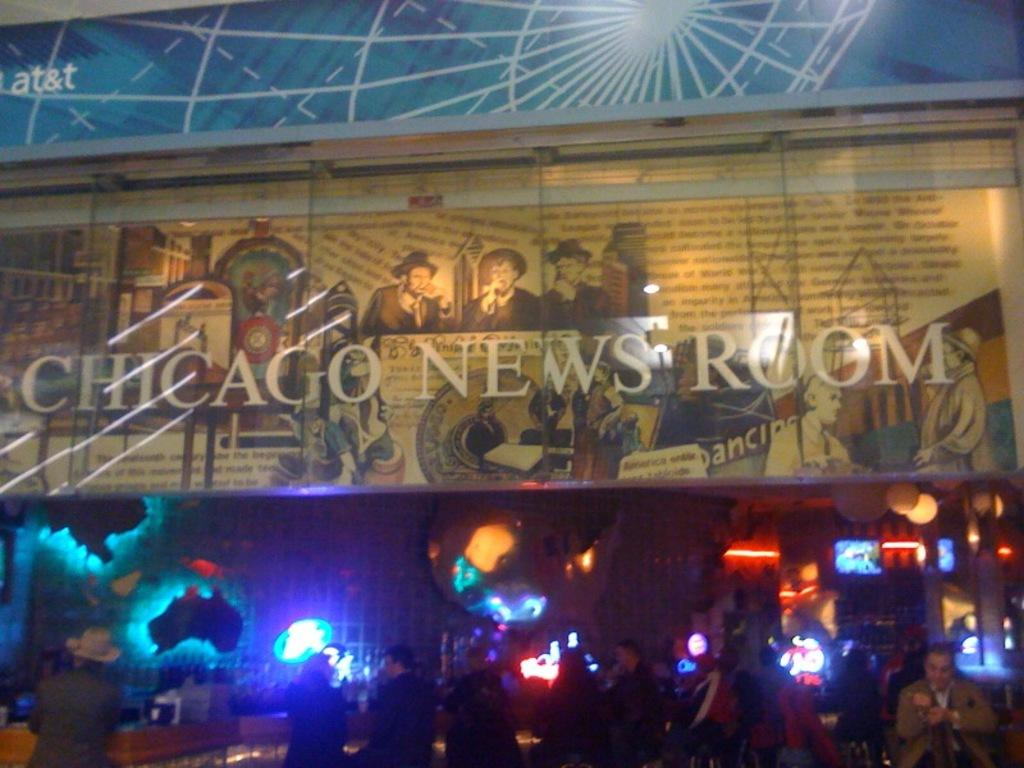What is the main object in the image with text on it? There is a sign board with text in the image. What can be seen at the bottom of the image? A group of people is standing at the bottom of the image. What can be seen in the background of the image? There are lights visible in the background of the image. How many chairs are being played by the group of people in the image? There are no chairs present in the image, and the group of people is not playing any instruments. 